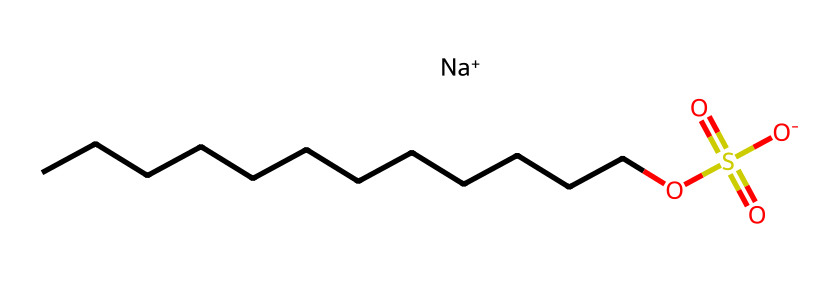What is the main functional group in this chemical? The chemical structure includes a sulfonate group (indicated by the -OS(=O)(=O)[O-] pattern), which is characteristic of sulfates.
Answer: sulfonate How many carbon atoms are present in this chemical? The longest carbon chain in the structure consists of 12 carbon atoms (the sequence CCCCCCCCCCCC), confirming that there are 12 total carbon atoms.
Answer: 12 What ion is present in the structure? The chemical contains a sodium ion (Na+), which is implied by the presence of [Na+] in the SMILES representation.
Answer: sodium What type of chemical is sodium lauryl sulfate? Sodium lauryl sulfate is classified as an anionic surfactant, primarily due to the presence of the negatively charged sulfonate group and its foaming properties.
Answer: anionic surfactant What is the total number of oxygen atoms in this chemical? The molecule features 4 oxygen atoms located in the sulfonate group and the structure's connectivity, with 3 in the -OS(=O)(=O)[O-] part and 1 being part of the sulfate connection.
Answer: 4 What properties does the long carbon chain confer to this chemical? The long carbon chain provides hydrophobic characteristics, which helps the molecule interact with oils and fats, allowing effective cleansing and foaming actions.
Answer: hydrophobic characteristics 